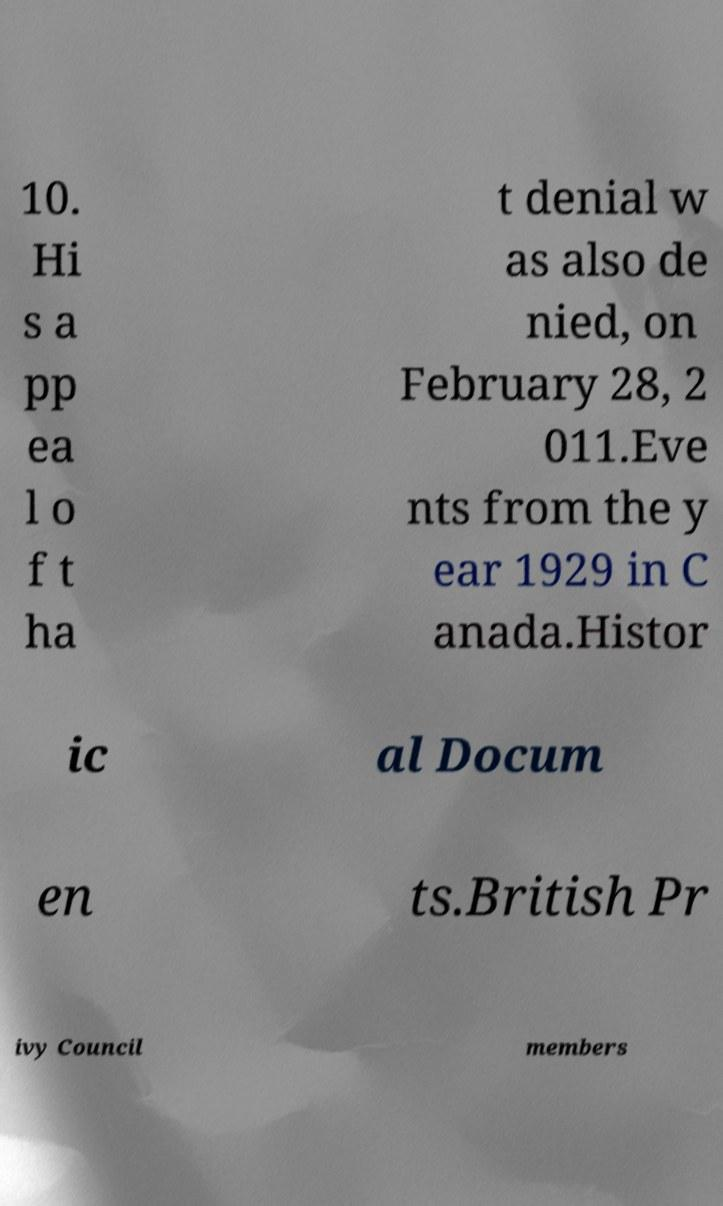Could you extract and type out the text from this image? 10. Hi s a pp ea l o f t ha t denial w as also de nied, on February 28, 2 011.Eve nts from the y ear 1929 in C anada.Histor ic al Docum en ts.British Pr ivy Council members 